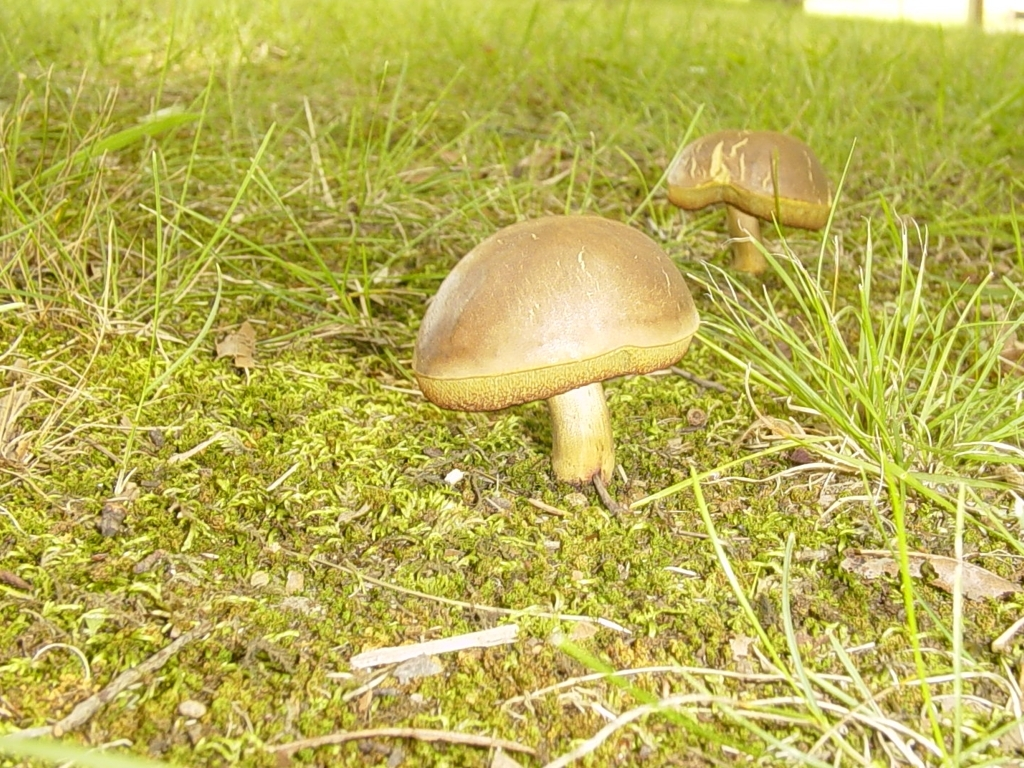What could be the significance of mushrooms in an ecosystem? Mushrooms play a crucial role in ecosystems as decomposers. They break down dead organic material, recycling nutrients back into the soil, which is essential for plant growth. Some mushrooms also form symbiotic relationships with plants, improving water and nutrient uptake for the host plant. 